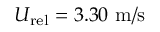<formula> <loc_0><loc_0><loc_500><loc_500>U _ { r e l } = 3 . 3 0 m / s</formula> 